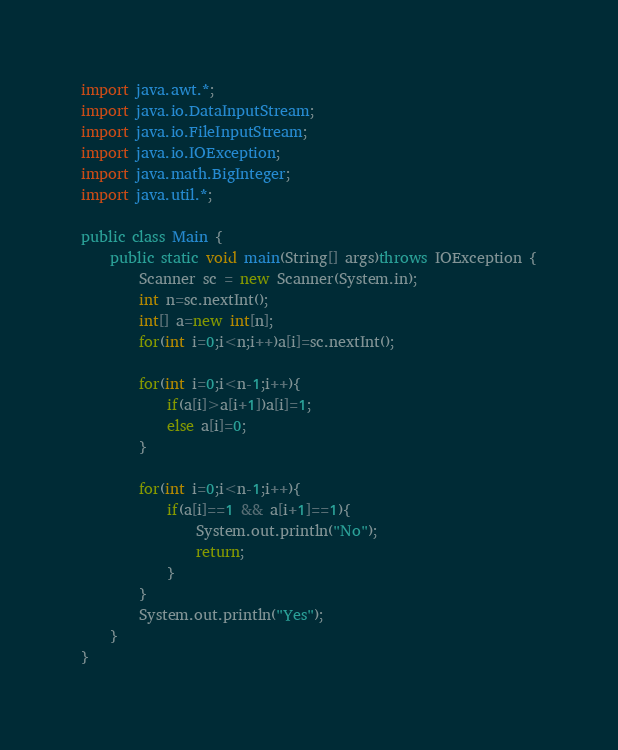Convert code to text. <code><loc_0><loc_0><loc_500><loc_500><_Java_>import java.awt.*;
import java.io.DataInputStream;
import java.io.FileInputStream;
import java.io.IOException;
import java.math.BigInteger;
import java.util.*;

public class Main {
    public static void main(String[] args)throws IOException {
        Scanner sc = new Scanner(System.in);
        int n=sc.nextInt();
        int[] a=new int[n];
        for(int i=0;i<n;i++)a[i]=sc.nextInt();

        for(int i=0;i<n-1;i++){
            if(a[i]>a[i+1])a[i]=1;
            else a[i]=0;
        }

        for(int i=0;i<n-1;i++){
            if(a[i]==1 && a[i+1]==1){
                System.out.println("No");
                return;
            }
        }
        System.out.println("Yes");
    }
}</code> 